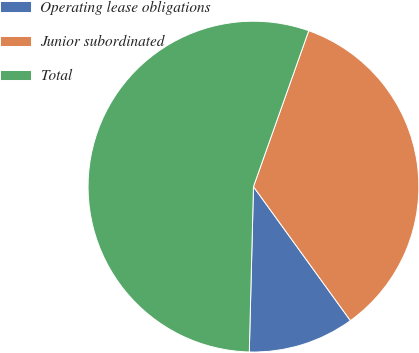Convert chart. <chart><loc_0><loc_0><loc_500><loc_500><pie_chart><fcel>Operating lease obligations<fcel>Junior subordinated<fcel>Total<nl><fcel>10.37%<fcel>34.61%<fcel>55.02%<nl></chart> 